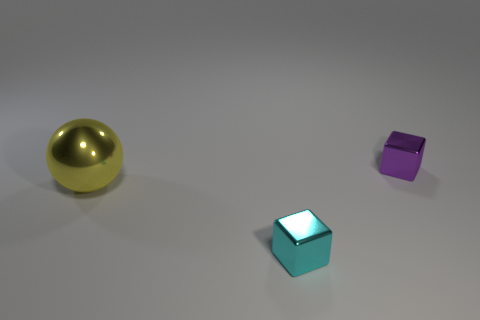How many other objects are the same size as the cyan shiny object?
Offer a terse response. 1. Do the cube behind the large metallic object and the object that is in front of the yellow metallic sphere have the same material?
Ensure brevity in your answer.  Yes. What size is the shiny thing on the left side of the small object left of the purple block?
Give a very brief answer. Large. Is there a small shiny thing that has the same color as the metallic sphere?
Ensure brevity in your answer.  No. Is the color of the metal cube behind the large yellow metal sphere the same as the thing in front of the big yellow shiny thing?
Offer a very short reply. No. There is a yellow metal object; what shape is it?
Make the answer very short. Sphere. There is a yellow sphere; how many metallic objects are to the right of it?
Your answer should be very brief. 2. What number of small red blocks have the same material as the small purple object?
Provide a succinct answer. 0. Is the thing that is on the right side of the cyan block made of the same material as the large thing?
Give a very brief answer. Yes. Are any small brown matte cylinders visible?
Provide a short and direct response. No. 